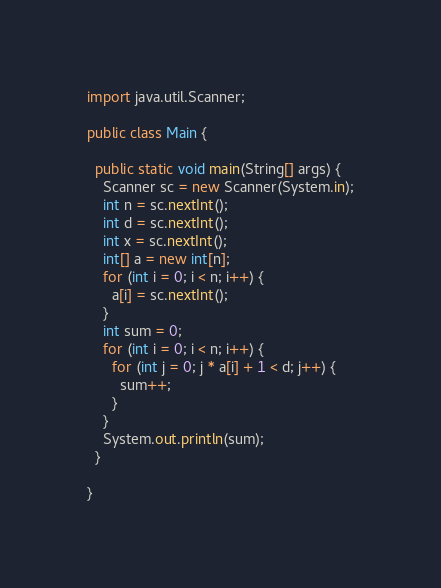Convert code to text. <code><loc_0><loc_0><loc_500><loc_500><_Java_>import java.util.Scanner;

public class Main {

  public static void main(String[] args) {
    Scanner sc = new Scanner(System.in);
    int n = sc.nextInt();
    int d = sc.nextInt();
    int x = sc.nextInt();
    int[] a = new int[n];
    for (int i = 0; i < n; i++) {
      a[i] = sc.nextInt();
    }
    int sum = 0;
    for (int i = 0; i < n; i++) {
      for (int j = 0; j * a[i] + 1 < d; j++) {
        sum++;
      }
    }
    System.out.println(sum);
  }

}
</code> 